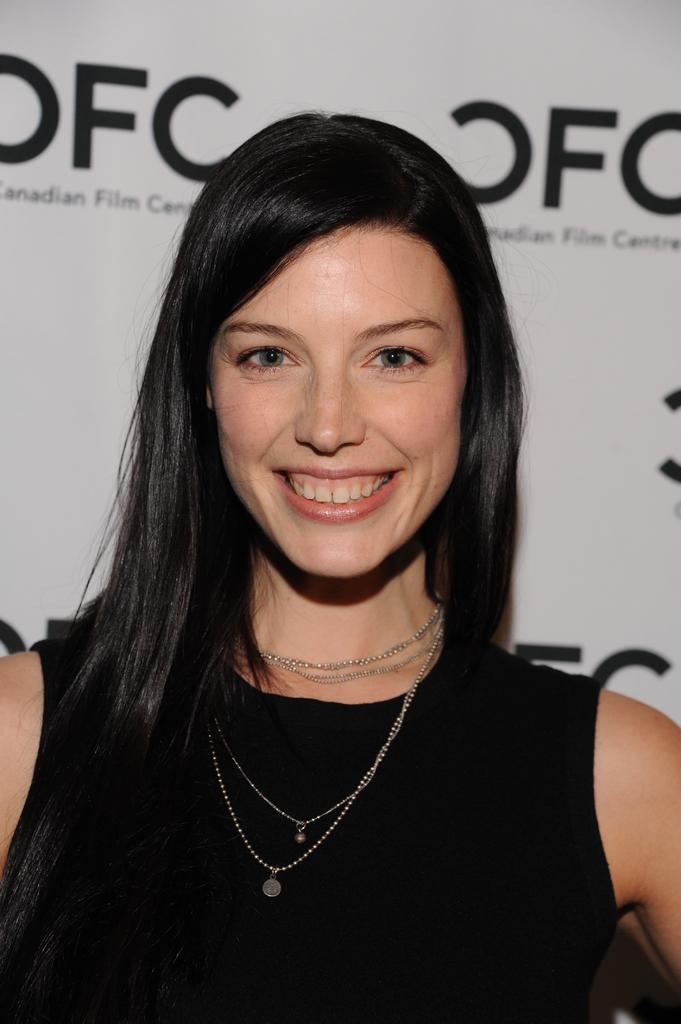In one or two sentences, can you explain what this image depicts? In this image in the center there is one woman who is smiling and in the background there is one board, on that board there is some text. 